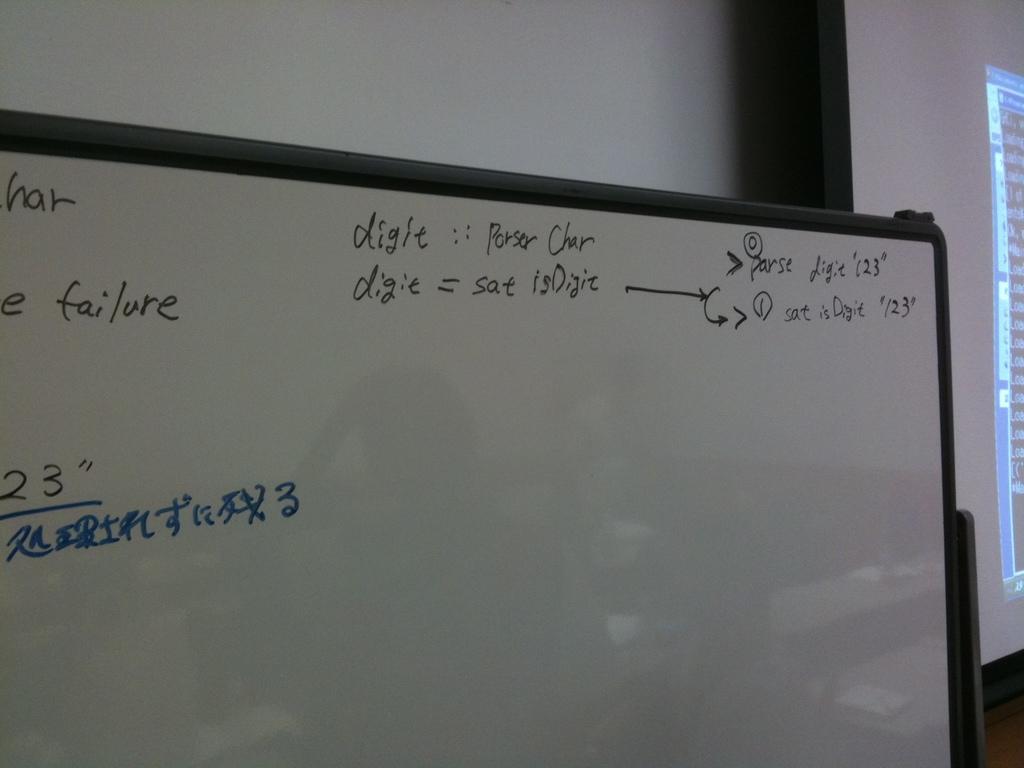What does digit equal?
Your answer should be compact. Sat isdigit. Is the word failure on the board?
Offer a very short reply. Yes. 